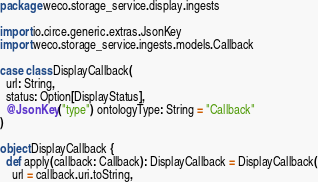<code> <loc_0><loc_0><loc_500><loc_500><_Scala_>package weco.storage_service.display.ingests

import io.circe.generic.extras.JsonKey
import weco.storage_service.ingests.models.Callback

case class DisplayCallback(
  url: String,
  status: Option[DisplayStatus],
  @JsonKey("type") ontologyType: String = "Callback"
)

object DisplayCallback {
  def apply(callback: Callback): DisplayCallback = DisplayCallback(
    url = callback.uri.toString,</code> 